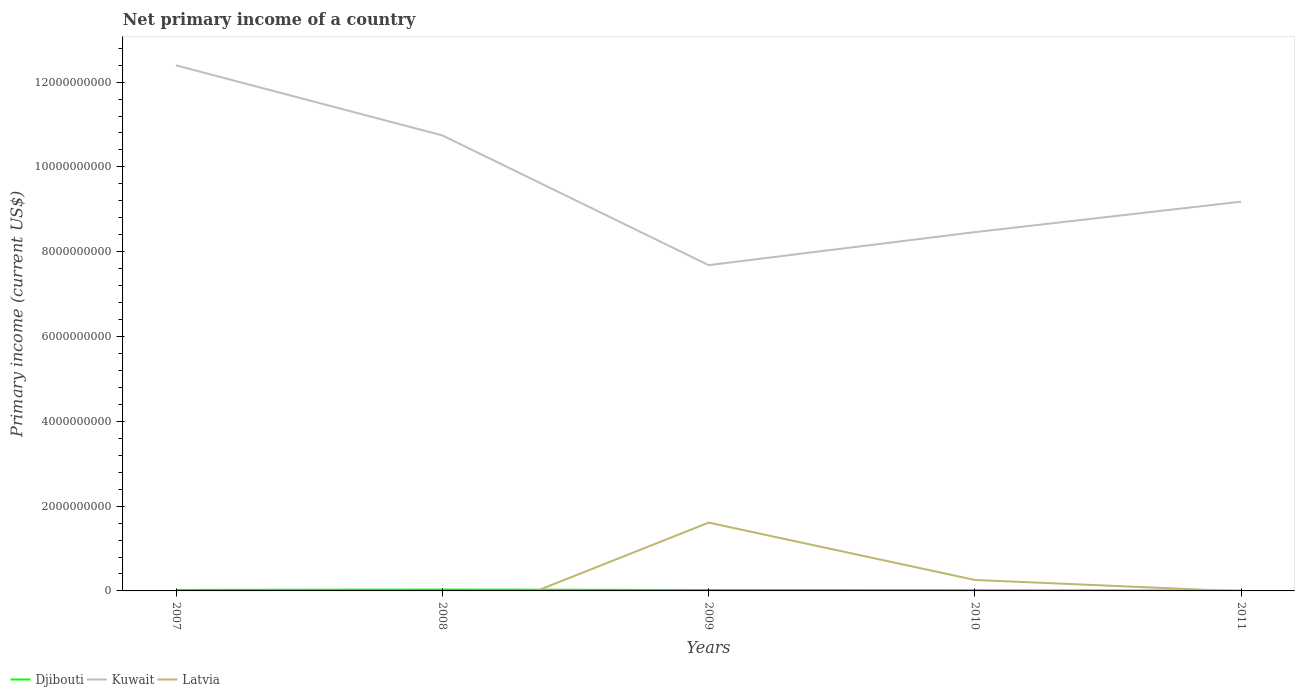How many different coloured lines are there?
Your response must be concise. 3. Across all years, what is the maximum primary income in Latvia?
Ensure brevity in your answer.  0. What is the total primary income in Kuwait in the graph?
Your answer should be compact. -7.79e+08. What is the difference between the highest and the second highest primary income in Latvia?
Your response must be concise. 1.61e+09. What is the difference between the highest and the lowest primary income in Kuwait?
Provide a short and direct response. 2. How many years are there in the graph?
Provide a succinct answer. 5. Are the values on the major ticks of Y-axis written in scientific E-notation?
Provide a short and direct response. No. Does the graph contain any zero values?
Your answer should be compact. Yes. Where does the legend appear in the graph?
Your answer should be very brief. Bottom left. How many legend labels are there?
Offer a terse response. 3. How are the legend labels stacked?
Provide a succinct answer. Horizontal. What is the title of the graph?
Give a very brief answer. Net primary income of a country. Does "Heavily indebted poor countries" appear as one of the legend labels in the graph?
Ensure brevity in your answer.  No. What is the label or title of the Y-axis?
Give a very brief answer. Primary income (current US$). What is the Primary income (current US$) of Djibouti in 2007?
Keep it short and to the point. 2.39e+07. What is the Primary income (current US$) in Kuwait in 2007?
Give a very brief answer. 1.24e+1. What is the Primary income (current US$) of Djibouti in 2008?
Your answer should be very brief. 3.27e+07. What is the Primary income (current US$) of Kuwait in 2008?
Your answer should be compact. 1.07e+1. What is the Primary income (current US$) of Latvia in 2008?
Ensure brevity in your answer.  0. What is the Primary income (current US$) in Djibouti in 2009?
Offer a terse response. 2.17e+07. What is the Primary income (current US$) in Kuwait in 2009?
Your answer should be very brief. 7.68e+09. What is the Primary income (current US$) in Latvia in 2009?
Your response must be concise. 1.61e+09. What is the Primary income (current US$) in Djibouti in 2010?
Provide a short and direct response. 1.74e+07. What is the Primary income (current US$) in Kuwait in 2010?
Provide a short and direct response. 8.46e+09. What is the Primary income (current US$) of Latvia in 2010?
Keep it short and to the point. 2.58e+08. What is the Primary income (current US$) in Djibouti in 2011?
Give a very brief answer. 8.74e+06. What is the Primary income (current US$) in Kuwait in 2011?
Ensure brevity in your answer.  9.18e+09. Across all years, what is the maximum Primary income (current US$) in Djibouti?
Ensure brevity in your answer.  3.27e+07. Across all years, what is the maximum Primary income (current US$) of Kuwait?
Provide a short and direct response. 1.24e+1. Across all years, what is the maximum Primary income (current US$) in Latvia?
Your answer should be compact. 1.61e+09. Across all years, what is the minimum Primary income (current US$) in Djibouti?
Give a very brief answer. 8.74e+06. Across all years, what is the minimum Primary income (current US$) of Kuwait?
Your answer should be compact. 7.68e+09. Across all years, what is the minimum Primary income (current US$) in Latvia?
Keep it short and to the point. 0. What is the total Primary income (current US$) of Djibouti in the graph?
Your response must be concise. 1.04e+08. What is the total Primary income (current US$) of Kuwait in the graph?
Your response must be concise. 4.85e+1. What is the total Primary income (current US$) in Latvia in the graph?
Your response must be concise. 1.87e+09. What is the difference between the Primary income (current US$) of Djibouti in 2007 and that in 2008?
Provide a short and direct response. -8.82e+06. What is the difference between the Primary income (current US$) in Kuwait in 2007 and that in 2008?
Offer a terse response. 1.65e+09. What is the difference between the Primary income (current US$) of Djibouti in 2007 and that in 2009?
Ensure brevity in your answer.  2.21e+06. What is the difference between the Primary income (current US$) in Kuwait in 2007 and that in 2009?
Offer a terse response. 4.71e+09. What is the difference between the Primary income (current US$) of Djibouti in 2007 and that in 2010?
Offer a terse response. 6.53e+06. What is the difference between the Primary income (current US$) of Kuwait in 2007 and that in 2010?
Your response must be concise. 3.93e+09. What is the difference between the Primary income (current US$) of Djibouti in 2007 and that in 2011?
Offer a very short reply. 1.51e+07. What is the difference between the Primary income (current US$) in Kuwait in 2007 and that in 2011?
Your answer should be very brief. 3.21e+09. What is the difference between the Primary income (current US$) in Djibouti in 2008 and that in 2009?
Keep it short and to the point. 1.10e+07. What is the difference between the Primary income (current US$) in Kuwait in 2008 and that in 2009?
Your response must be concise. 3.06e+09. What is the difference between the Primary income (current US$) of Djibouti in 2008 and that in 2010?
Give a very brief answer. 1.53e+07. What is the difference between the Primary income (current US$) of Kuwait in 2008 and that in 2010?
Offer a terse response. 2.28e+09. What is the difference between the Primary income (current US$) of Djibouti in 2008 and that in 2011?
Offer a very short reply. 2.40e+07. What is the difference between the Primary income (current US$) in Kuwait in 2008 and that in 2011?
Provide a short and direct response. 1.56e+09. What is the difference between the Primary income (current US$) of Djibouti in 2009 and that in 2010?
Offer a very short reply. 4.32e+06. What is the difference between the Primary income (current US$) of Kuwait in 2009 and that in 2010?
Offer a very short reply. -7.79e+08. What is the difference between the Primary income (current US$) of Latvia in 2009 and that in 2010?
Make the answer very short. 1.35e+09. What is the difference between the Primary income (current US$) of Djibouti in 2009 and that in 2011?
Keep it short and to the point. 1.29e+07. What is the difference between the Primary income (current US$) of Kuwait in 2009 and that in 2011?
Your answer should be very brief. -1.50e+09. What is the difference between the Primary income (current US$) of Djibouti in 2010 and that in 2011?
Make the answer very short. 8.61e+06. What is the difference between the Primary income (current US$) in Kuwait in 2010 and that in 2011?
Make the answer very short. -7.18e+08. What is the difference between the Primary income (current US$) in Djibouti in 2007 and the Primary income (current US$) in Kuwait in 2008?
Give a very brief answer. -1.07e+1. What is the difference between the Primary income (current US$) in Djibouti in 2007 and the Primary income (current US$) in Kuwait in 2009?
Offer a terse response. -7.66e+09. What is the difference between the Primary income (current US$) in Djibouti in 2007 and the Primary income (current US$) in Latvia in 2009?
Ensure brevity in your answer.  -1.59e+09. What is the difference between the Primary income (current US$) in Kuwait in 2007 and the Primary income (current US$) in Latvia in 2009?
Your answer should be very brief. 1.08e+1. What is the difference between the Primary income (current US$) in Djibouti in 2007 and the Primary income (current US$) in Kuwait in 2010?
Your response must be concise. -8.44e+09. What is the difference between the Primary income (current US$) of Djibouti in 2007 and the Primary income (current US$) of Latvia in 2010?
Your response must be concise. -2.34e+08. What is the difference between the Primary income (current US$) of Kuwait in 2007 and the Primary income (current US$) of Latvia in 2010?
Offer a terse response. 1.21e+1. What is the difference between the Primary income (current US$) of Djibouti in 2007 and the Primary income (current US$) of Kuwait in 2011?
Make the answer very short. -9.16e+09. What is the difference between the Primary income (current US$) of Djibouti in 2008 and the Primary income (current US$) of Kuwait in 2009?
Your answer should be very brief. -7.65e+09. What is the difference between the Primary income (current US$) in Djibouti in 2008 and the Primary income (current US$) in Latvia in 2009?
Give a very brief answer. -1.58e+09. What is the difference between the Primary income (current US$) in Kuwait in 2008 and the Primary income (current US$) in Latvia in 2009?
Provide a short and direct response. 9.13e+09. What is the difference between the Primary income (current US$) of Djibouti in 2008 and the Primary income (current US$) of Kuwait in 2010?
Give a very brief answer. -8.43e+09. What is the difference between the Primary income (current US$) of Djibouti in 2008 and the Primary income (current US$) of Latvia in 2010?
Offer a terse response. -2.26e+08. What is the difference between the Primary income (current US$) in Kuwait in 2008 and the Primary income (current US$) in Latvia in 2010?
Your answer should be compact. 1.05e+1. What is the difference between the Primary income (current US$) in Djibouti in 2008 and the Primary income (current US$) in Kuwait in 2011?
Your answer should be compact. -9.15e+09. What is the difference between the Primary income (current US$) in Djibouti in 2009 and the Primary income (current US$) in Kuwait in 2010?
Give a very brief answer. -8.44e+09. What is the difference between the Primary income (current US$) in Djibouti in 2009 and the Primary income (current US$) in Latvia in 2010?
Your answer should be compact. -2.37e+08. What is the difference between the Primary income (current US$) of Kuwait in 2009 and the Primary income (current US$) of Latvia in 2010?
Your response must be concise. 7.42e+09. What is the difference between the Primary income (current US$) in Djibouti in 2009 and the Primary income (current US$) in Kuwait in 2011?
Provide a succinct answer. -9.16e+09. What is the difference between the Primary income (current US$) in Djibouti in 2010 and the Primary income (current US$) in Kuwait in 2011?
Offer a very short reply. -9.16e+09. What is the average Primary income (current US$) in Djibouti per year?
Offer a terse response. 2.09e+07. What is the average Primary income (current US$) of Kuwait per year?
Your answer should be compact. 9.69e+09. What is the average Primary income (current US$) of Latvia per year?
Provide a short and direct response. 3.74e+08. In the year 2007, what is the difference between the Primary income (current US$) in Djibouti and Primary income (current US$) in Kuwait?
Keep it short and to the point. -1.24e+1. In the year 2008, what is the difference between the Primary income (current US$) in Djibouti and Primary income (current US$) in Kuwait?
Ensure brevity in your answer.  -1.07e+1. In the year 2009, what is the difference between the Primary income (current US$) of Djibouti and Primary income (current US$) of Kuwait?
Keep it short and to the point. -7.66e+09. In the year 2009, what is the difference between the Primary income (current US$) in Djibouti and Primary income (current US$) in Latvia?
Offer a terse response. -1.59e+09. In the year 2009, what is the difference between the Primary income (current US$) of Kuwait and Primary income (current US$) of Latvia?
Ensure brevity in your answer.  6.07e+09. In the year 2010, what is the difference between the Primary income (current US$) in Djibouti and Primary income (current US$) in Kuwait?
Offer a very short reply. -8.44e+09. In the year 2010, what is the difference between the Primary income (current US$) in Djibouti and Primary income (current US$) in Latvia?
Offer a terse response. -2.41e+08. In the year 2010, what is the difference between the Primary income (current US$) of Kuwait and Primary income (current US$) of Latvia?
Provide a succinct answer. 8.20e+09. In the year 2011, what is the difference between the Primary income (current US$) in Djibouti and Primary income (current US$) in Kuwait?
Keep it short and to the point. -9.17e+09. What is the ratio of the Primary income (current US$) in Djibouti in 2007 to that in 2008?
Your response must be concise. 0.73. What is the ratio of the Primary income (current US$) in Kuwait in 2007 to that in 2008?
Provide a short and direct response. 1.15. What is the ratio of the Primary income (current US$) in Djibouti in 2007 to that in 2009?
Give a very brief answer. 1.1. What is the ratio of the Primary income (current US$) of Kuwait in 2007 to that in 2009?
Ensure brevity in your answer.  1.61. What is the ratio of the Primary income (current US$) in Djibouti in 2007 to that in 2010?
Give a very brief answer. 1.38. What is the ratio of the Primary income (current US$) in Kuwait in 2007 to that in 2010?
Your response must be concise. 1.46. What is the ratio of the Primary income (current US$) in Djibouti in 2007 to that in 2011?
Your answer should be compact. 2.73. What is the ratio of the Primary income (current US$) of Kuwait in 2007 to that in 2011?
Offer a very short reply. 1.35. What is the ratio of the Primary income (current US$) of Djibouti in 2008 to that in 2009?
Your answer should be very brief. 1.51. What is the ratio of the Primary income (current US$) of Kuwait in 2008 to that in 2009?
Keep it short and to the point. 1.4. What is the ratio of the Primary income (current US$) in Djibouti in 2008 to that in 2010?
Offer a very short reply. 1.88. What is the ratio of the Primary income (current US$) in Kuwait in 2008 to that in 2010?
Your answer should be very brief. 1.27. What is the ratio of the Primary income (current US$) of Djibouti in 2008 to that in 2011?
Make the answer very short. 3.74. What is the ratio of the Primary income (current US$) of Kuwait in 2008 to that in 2011?
Keep it short and to the point. 1.17. What is the ratio of the Primary income (current US$) of Djibouti in 2009 to that in 2010?
Make the answer very short. 1.25. What is the ratio of the Primary income (current US$) in Kuwait in 2009 to that in 2010?
Ensure brevity in your answer.  0.91. What is the ratio of the Primary income (current US$) of Latvia in 2009 to that in 2010?
Ensure brevity in your answer.  6.24. What is the ratio of the Primary income (current US$) of Djibouti in 2009 to that in 2011?
Keep it short and to the point. 2.48. What is the ratio of the Primary income (current US$) in Kuwait in 2009 to that in 2011?
Make the answer very short. 0.84. What is the ratio of the Primary income (current US$) in Djibouti in 2010 to that in 2011?
Your answer should be compact. 1.99. What is the ratio of the Primary income (current US$) in Kuwait in 2010 to that in 2011?
Provide a succinct answer. 0.92. What is the difference between the highest and the second highest Primary income (current US$) in Djibouti?
Give a very brief answer. 8.82e+06. What is the difference between the highest and the second highest Primary income (current US$) of Kuwait?
Keep it short and to the point. 1.65e+09. What is the difference between the highest and the lowest Primary income (current US$) in Djibouti?
Your answer should be compact. 2.40e+07. What is the difference between the highest and the lowest Primary income (current US$) in Kuwait?
Provide a succinct answer. 4.71e+09. What is the difference between the highest and the lowest Primary income (current US$) of Latvia?
Keep it short and to the point. 1.61e+09. 